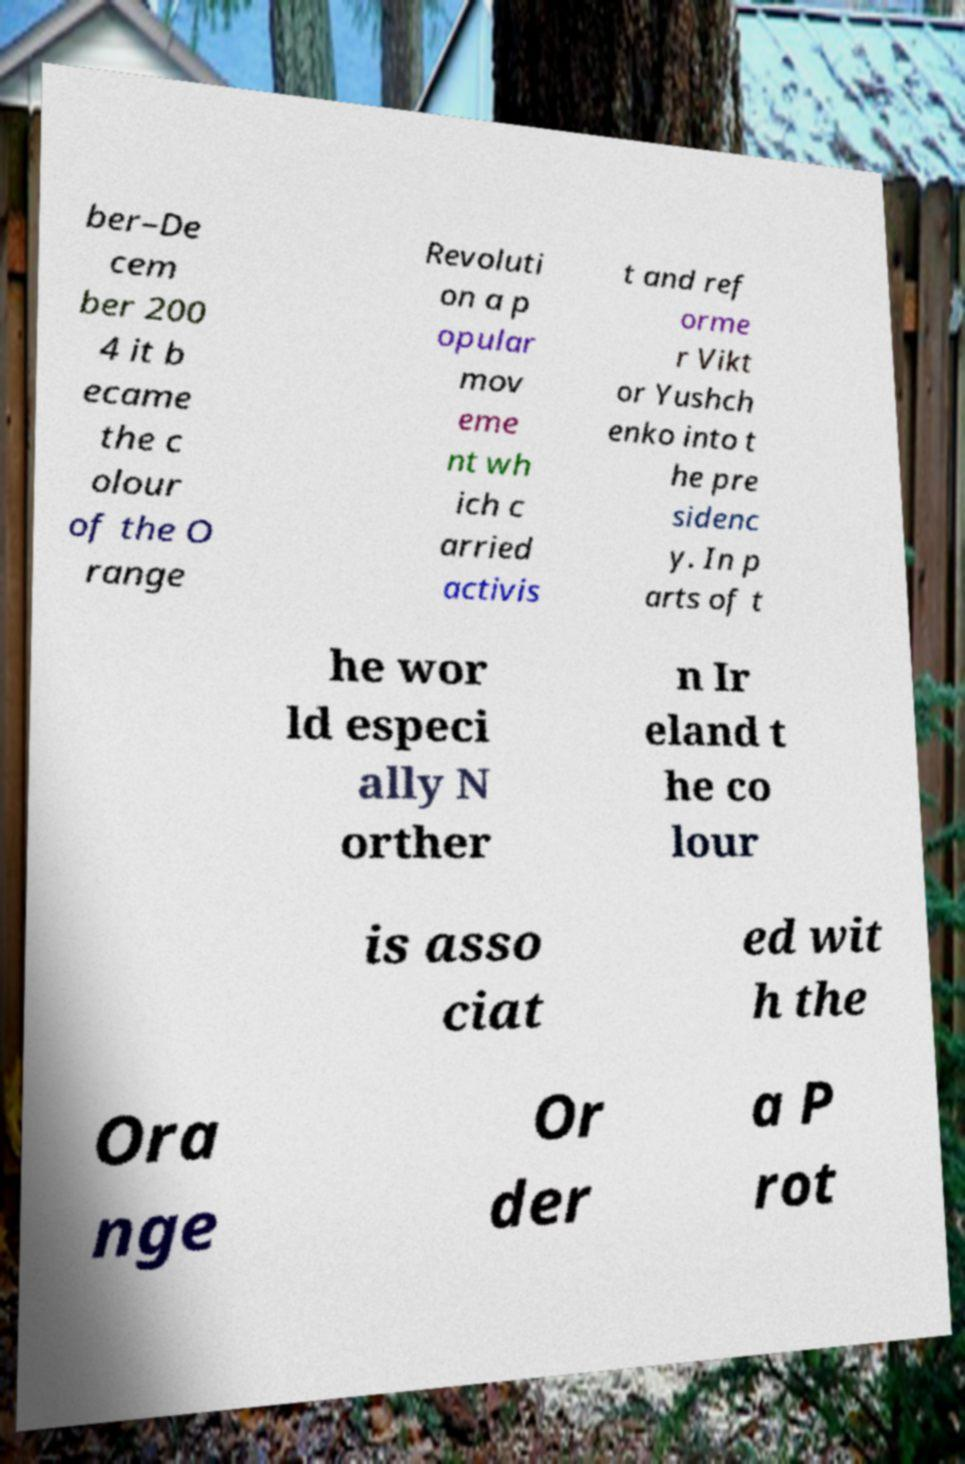There's text embedded in this image that I need extracted. Can you transcribe it verbatim? ber–De cem ber 200 4 it b ecame the c olour of the O range Revoluti on a p opular mov eme nt wh ich c arried activis t and ref orme r Vikt or Yushch enko into t he pre sidenc y. In p arts of t he wor ld especi ally N orther n Ir eland t he co lour is asso ciat ed wit h the Ora nge Or der a P rot 